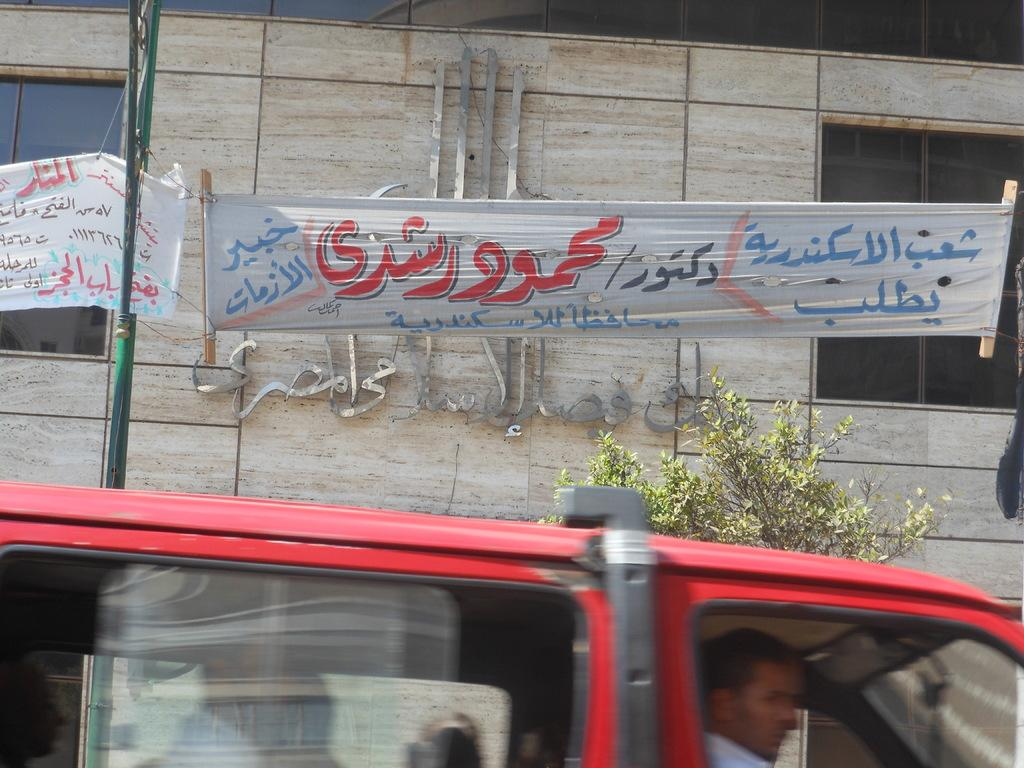What is the main subject of the image? There is a vehicle in the image. Who is inside the vehicle? A man is sitting inside the vehicle. What can be seen in the background of the image? There is a wall, a banner, a tree, a pole, and a window in the background of the image. What type of toe is visible on the banner in the image? There are no toes present in the image, as it features a vehicle, a man, and various background elements. 